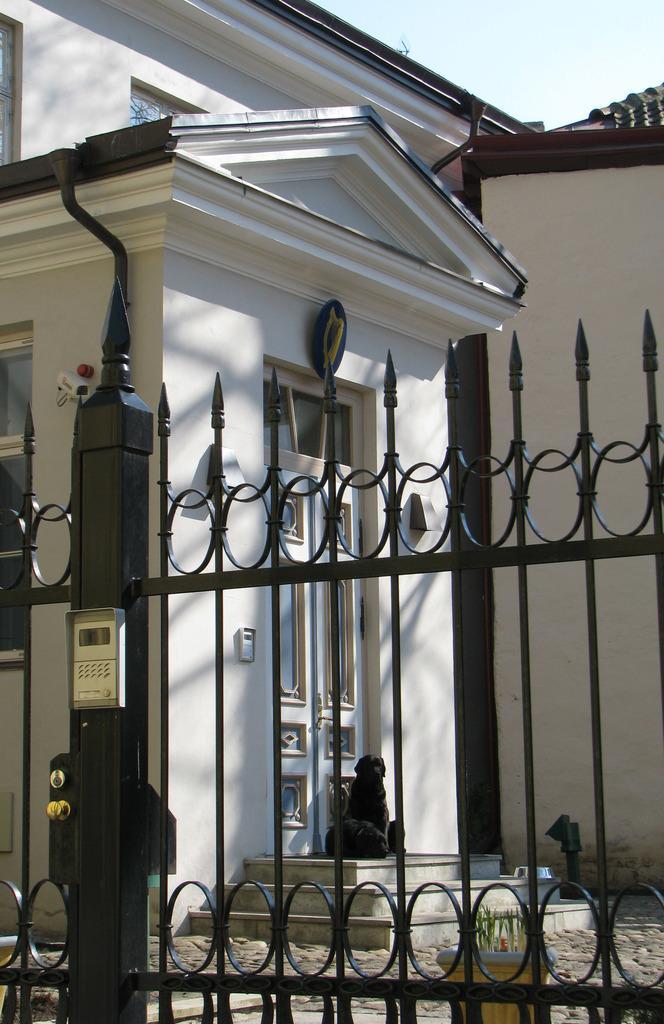Could you give a brief overview of what you see in this image? In this image we can see a gate with a device on that. In the back there is a building with doors and window. In front of the building there is a dog and steps. At the top of the image there is sky. And there is a CCTV camera on the wall. Near to the gate there is a pot with a plant. 